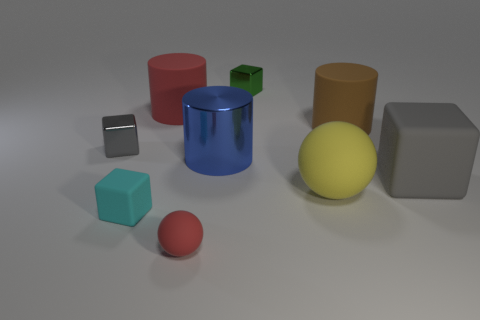Subtract all gray blocks. How many were subtracted if there are1gray blocks left? 1 Subtract 1 blocks. How many blocks are left? 3 Add 1 tiny cyan shiny cylinders. How many objects exist? 10 Subtract all blocks. How many objects are left? 5 Add 3 blue metal things. How many blue metal things are left? 4 Add 4 green metal things. How many green metal things exist? 5 Subtract 0 cyan spheres. How many objects are left? 9 Subtract all large green shiny cylinders. Subtract all gray blocks. How many objects are left? 7 